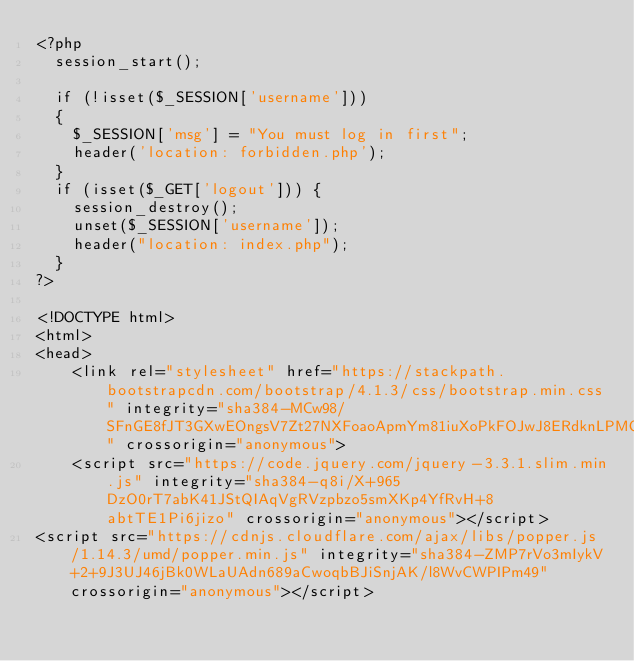<code> <loc_0><loc_0><loc_500><loc_500><_PHP_><?php 
  session_start(); 

  if (!isset($_SESSION['username'])) 
  {
  	$_SESSION['msg'] = "You must log in first";
  	header('location: forbidden.php');
  }
  if (isset($_GET['logout'])) {
  	session_destroy();
  	unset($_SESSION['username']);
  	header("location: index.php");
  }
?>

<!DOCTYPE html>
<html>
<head>
	<link rel="stylesheet" href="https://stackpath.bootstrapcdn.com/bootstrap/4.1.3/css/bootstrap.min.css" integrity="sha384-MCw98/SFnGE8fJT3GXwEOngsV7Zt27NXFoaoApmYm81iuXoPkFOJwJ8ERdknLPMO" crossorigin="anonymous">
	<script src="https://code.jquery.com/jquery-3.3.1.slim.min.js" integrity="sha384-q8i/X+965DzO0rT7abK41JStQIAqVgRVzpbzo5smXKp4YfRvH+8abtTE1Pi6jizo" crossorigin="anonymous"></script>
<script src="https://cdnjs.cloudflare.com/ajax/libs/popper.js/1.14.3/umd/popper.min.js" integrity="sha384-ZMP7rVo3mIykV+2+9J3UJ46jBk0WLaUAdn689aCwoqbBJiSnjAK/l8WvCWPIPm49" crossorigin="anonymous"></script></code> 